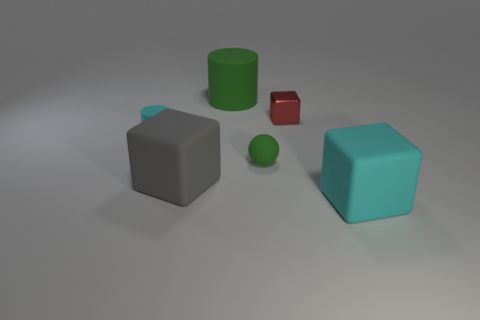Subtract all big gray cubes. How many cubes are left? 2 Subtract all cyan cylinders. How many cylinders are left? 1 Add 1 cubes. How many objects exist? 7 Subtract 1 blocks. How many blocks are left? 2 Subtract all cylinders. How many objects are left? 4 Subtract all small purple rubber cylinders. Subtract all tiny red shiny things. How many objects are left? 5 Add 3 large gray objects. How many large gray objects are left? 4 Add 6 purple shiny balls. How many purple shiny balls exist? 6 Subtract 0 purple balls. How many objects are left? 6 Subtract all yellow blocks. Subtract all gray cylinders. How many blocks are left? 3 